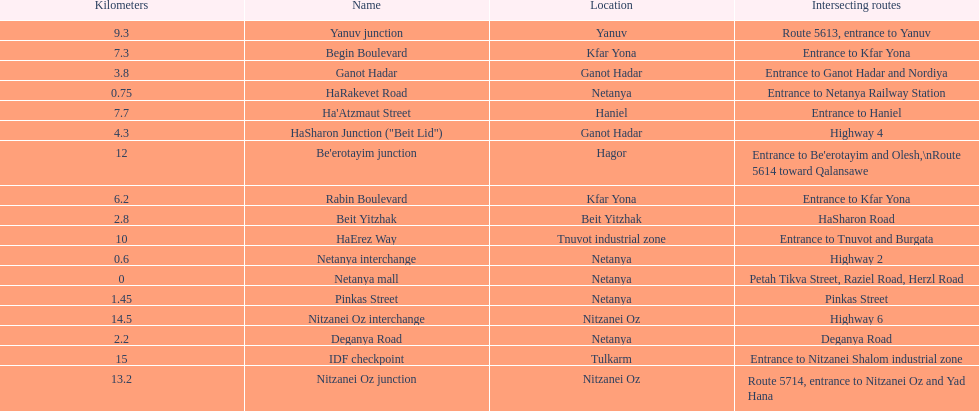After you complete deganya road, what portion comes next? Beit Yitzhak. Could you parse the entire table? {'header': ['Kilometers', 'Name', 'Location', 'Intersecting routes'], 'rows': [['9.3', 'Yanuv junction', 'Yanuv', 'Route 5613, entrance to Yanuv'], ['7.3', 'Begin Boulevard', 'Kfar Yona', 'Entrance to Kfar Yona'], ['3.8', 'Ganot Hadar', 'Ganot Hadar', 'Entrance to Ganot Hadar and Nordiya'], ['0.75', 'HaRakevet Road', 'Netanya', 'Entrance to Netanya Railway Station'], ['7.7', "Ha'Atzmaut Street", 'Haniel', 'Entrance to Haniel'], ['4.3', 'HaSharon Junction ("Beit Lid")', 'Ganot Hadar', 'Highway 4'], ['12', "Be'erotayim junction", 'Hagor', "Entrance to Be'erotayim and Olesh,\\nRoute 5614 toward Qalansawe"], ['6.2', 'Rabin Boulevard', 'Kfar Yona', 'Entrance to Kfar Yona'], ['2.8', 'Beit Yitzhak', 'Beit Yitzhak', 'HaSharon Road'], ['10', 'HaErez Way', 'Tnuvot industrial zone', 'Entrance to Tnuvot and Burgata'], ['0.6', 'Netanya interchange', 'Netanya', 'Highway 2'], ['0', 'Netanya mall', 'Netanya', 'Petah Tikva Street, Raziel Road, Herzl Road'], ['1.45', 'Pinkas Street', 'Netanya', 'Pinkas Street'], ['14.5', 'Nitzanei Oz interchange', 'Nitzanei Oz', 'Highway 6'], ['2.2', 'Deganya Road', 'Netanya', 'Deganya Road'], ['15', 'IDF checkpoint', 'Tulkarm', 'Entrance to Nitzanei Shalom industrial zone'], ['13.2', 'Nitzanei Oz junction', 'Nitzanei Oz', 'Route 5714, entrance to Nitzanei Oz and Yad Hana']]} 